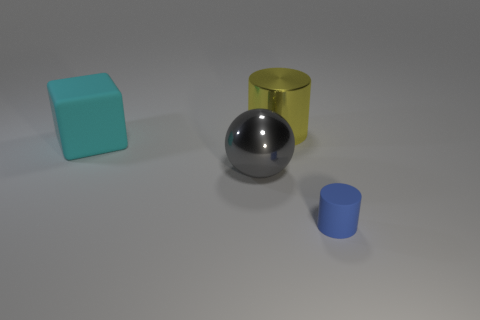Add 1 red metal cylinders. How many objects exist? 5 Subtract 2 cylinders. How many cylinders are left? 0 Subtract all blue cylinders. How many cylinders are left? 1 Add 2 gray metallic balls. How many gray metallic balls are left? 3 Add 1 large brown metallic spheres. How many large brown metallic spheres exist? 1 Subtract 0 blue cubes. How many objects are left? 4 Subtract all cubes. How many objects are left? 3 Subtract all brown cylinders. Subtract all cyan cubes. How many cylinders are left? 2 Subtract all tiny cyan rubber blocks. Subtract all big cyan rubber blocks. How many objects are left? 3 